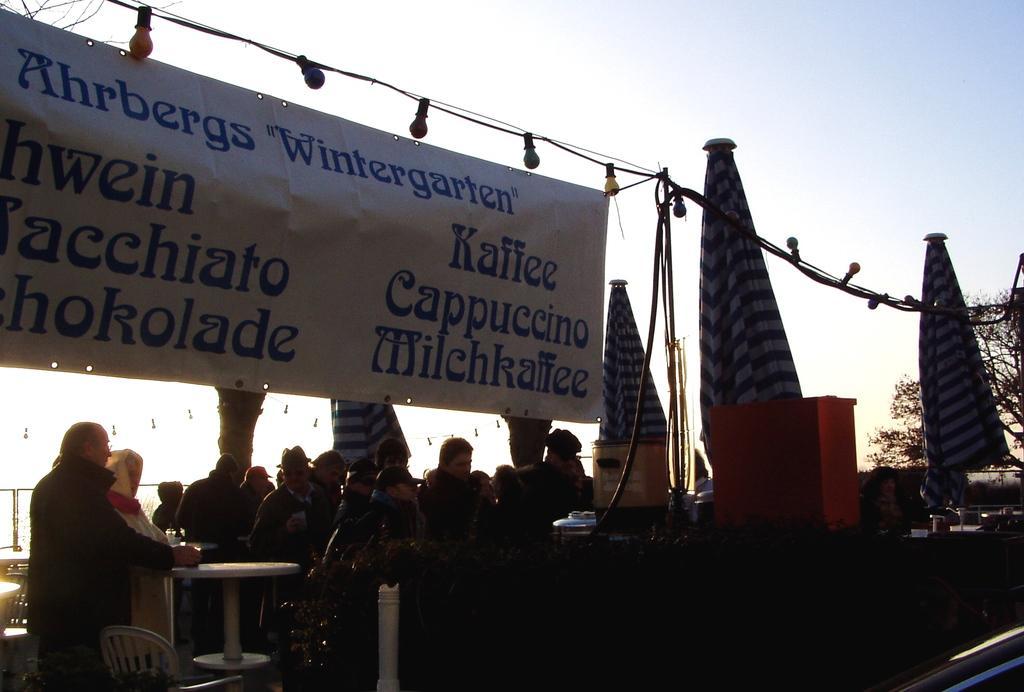How would you summarize this image in a sentence or two? As we can see in the image there is a sky and a banner and few people standing and sitting here and there and there is a table. 